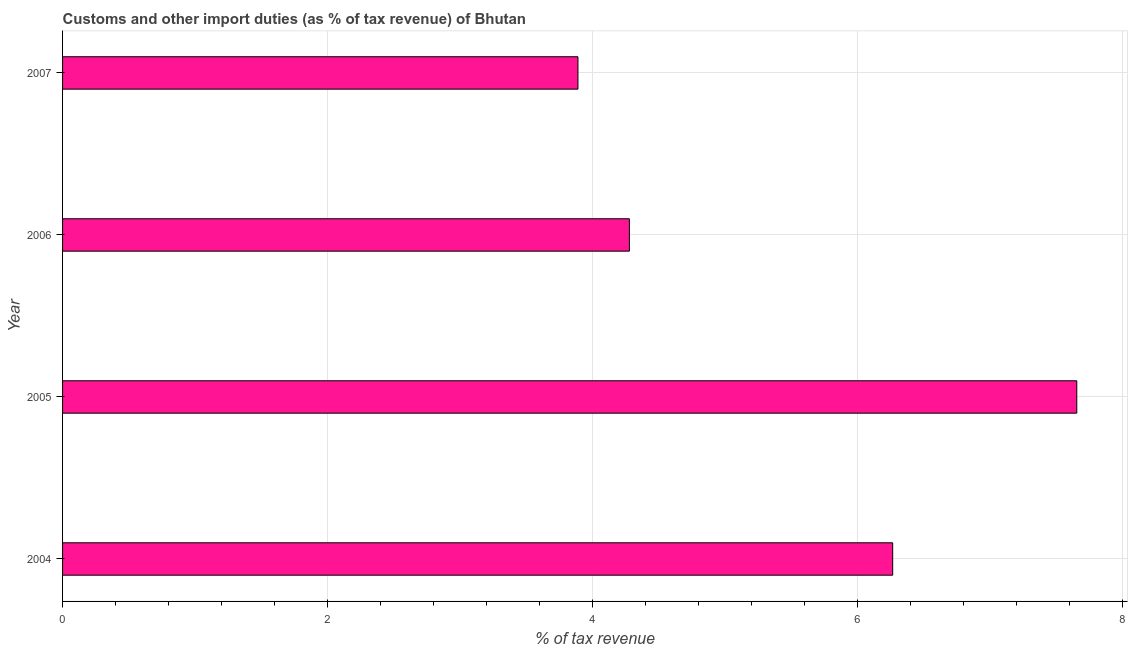Does the graph contain any zero values?
Ensure brevity in your answer.  No. What is the title of the graph?
Your response must be concise. Customs and other import duties (as % of tax revenue) of Bhutan. What is the label or title of the X-axis?
Your answer should be very brief. % of tax revenue. What is the customs and other import duties in 2005?
Provide a short and direct response. 7.66. Across all years, what is the maximum customs and other import duties?
Provide a short and direct response. 7.66. Across all years, what is the minimum customs and other import duties?
Your answer should be compact. 3.89. In which year was the customs and other import duties maximum?
Offer a terse response. 2005. What is the sum of the customs and other import duties?
Keep it short and to the point. 22.09. What is the difference between the customs and other import duties in 2004 and 2005?
Ensure brevity in your answer.  -1.39. What is the average customs and other import duties per year?
Give a very brief answer. 5.52. What is the median customs and other import duties?
Keep it short and to the point. 5.27. Do a majority of the years between 2007 and 2004 (inclusive) have customs and other import duties greater than 7.6 %?
Keep it short and to the point. Yes. What is the ratio of the customs and other import duties in 2004 to that in 2005?
Offer a terse response. 0.82. Is the customs and other import duties in 2006 less than that in 2007?
Ensure brevity in your answer.  No. Is the difference between the customs and other import duties in 2004 and 2005 greater than the difference between any two years?
Give a very brief answer. No. What is the difference between the highest and the second highest customs and other import duties?
Make the answer very short. 1.39. Is the sum of the customs and other import duties in 2004 and 2005 greater than the maximum customs and other import duties across all years?
Ensure brevity in your answer.  Yes. What is the difference between the highest and the lowest customs and other import duties?
Offer a very short reply. 3.77. What is the difference between two consecutive major ticks on the X-axis?
Give a very brief answer. 2. Are the values on the major ticks of X-axis written in scientific E-notation?
Offer a terse response. No. What is the % of tax revenue in 2004?
Ensure brevity in your answer.  6.27. What is the % of tax revenue in 2005?
Your response must be concise. 7.66. What is the % of tax revenue of 2006?
Your answer should be compact. 4.28. What is the % of tax revenue in 2007?
Keep it short and to the point. 3.89. What is the difference between the % of tax revenue in 2004 and 2005?
Give a very brief answer. -1.39. What is the difference between the % of tax revenue in 2004 and 2006?
Your response must be concise. 1.99. What is the difference between the % of tax revenue in 2004 and 2007?
Offer a very short reply. 2.38. What is the difference between the % of tax revenue in 2005 and 2006?
Offer a very short reply. 3.38. What is the difference between the % of tax revenue in 2005 and 2007?
Provide a succinct answer. 3.77. What is the difference between the % of tax revenue in 2006 and 2007?
Offer a very short reply. 0.39. What is the ratio of the % of tax revenue in 2004 to that in 2005?
Offer a very short reply. 0.82. What is the ratio of the % of tax revenue in 2004 to that in 2006?
Give a very brief answer. 1.47. What is the ratio of the % of tax revenue in 2004 to that in 2007?
Your answer should be compact. 1.61. What is the ratio of the % of tax revenue in 2005 to that in 2006?
Provide a short and direct response. 1.79. What is the ratio of the % of tax revenue in 2005 to that in 2007?
Offer a very short reply. 1.97. What is the ratio of the % of tax revenue in 2006 to that in 2007?
Your answer should be very brief. 1.1. 